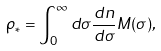Convert formula to latex. <formula><loc_0><loc_0><loc_500><loc_500>\rho _ { * } = \int _ { 0 } ^ { \infty } d \sigma \frac { d n } { d \sigma } M ( \sigma ) ,</formula> 